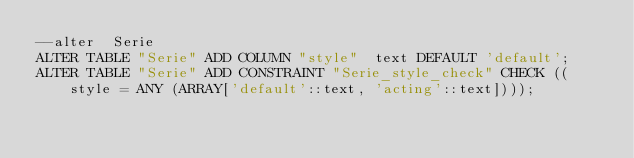<code> <loc_0><loc_0><loc_500><loc_500><_SQL_>--alter  Serie
ALTER TABLE "Serie" ADD COLUMN "style"  text DEFAULT 'default';
ALTER TABLE "Serie" ADD CONSTRAINT "Serie_style_check" CHECK ((style = ANY (ARRAY['default'::text, 'acting'::text])));

</code> 